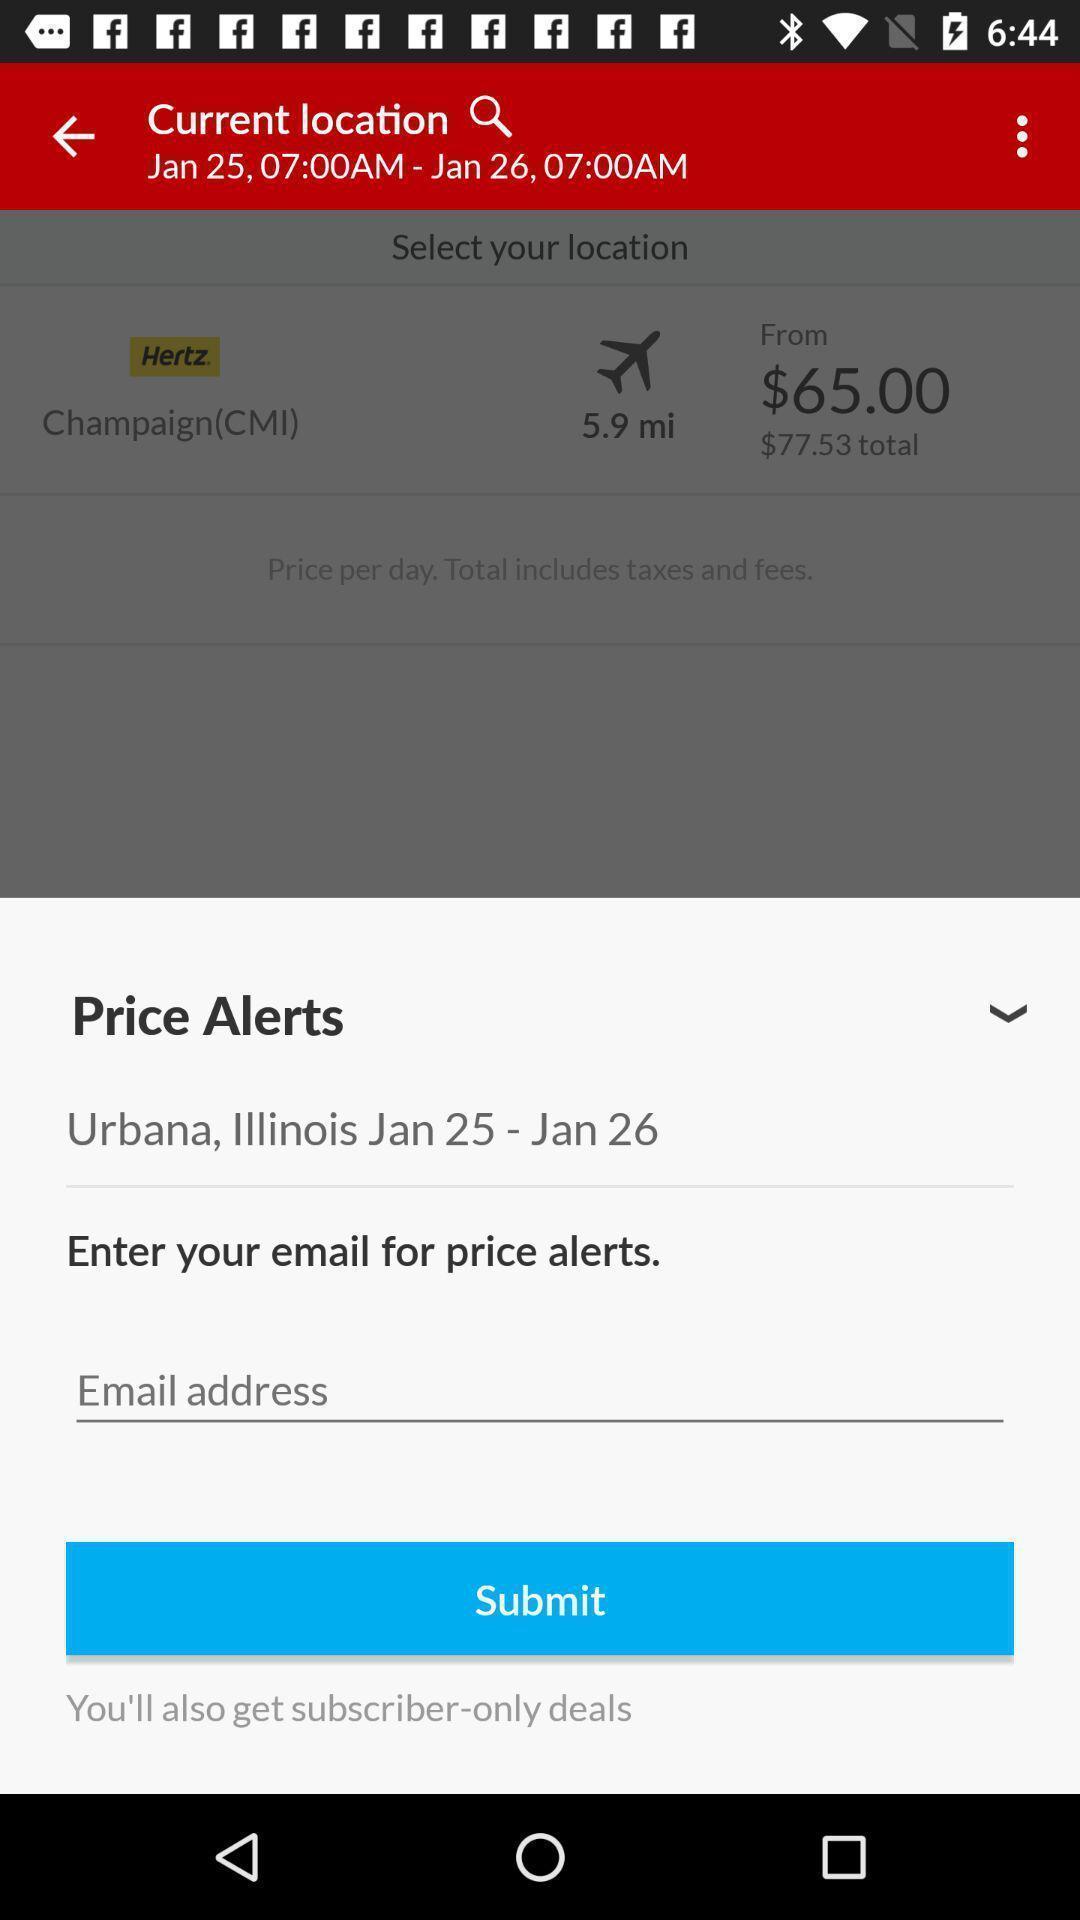Tell me about the visual elements in this screen capture. Widget showing details to be enter to get alerts. 